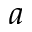<formula> <loc_0><loc_0><loc_500><loc_500>a</formula> 